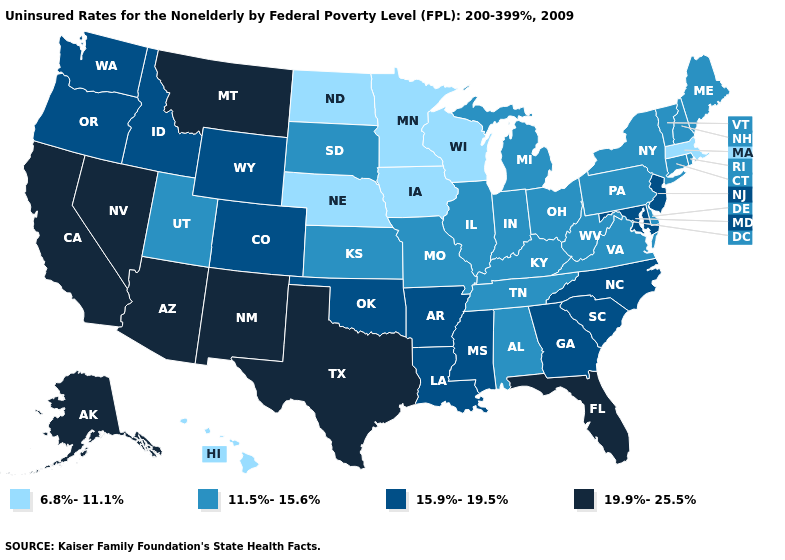What is the value of Maine?
Be succinct. 11.5%-15.6%. Name the states that have a value in the range 6.8%-11.1%?
Answer briefly. Hawaii, Iowa, Massachusetts, Minnesota, Nebraska, North Dakota, Wisconsin. Among the states that border Kansas , which have the lowest value?
Keep it brief. Nebraska. What is the value of Florida?
Keep it brief. 19.9%-25.5%. Among the states that border Indiana , which have the highest value?
Short answer required. Illinois, Kentucky, Michigan, Ohio. Name the states that have a value in the range 6.8%-11.1%?
Answer briefly. Hawaii, Iowa, Massachusetts, Minnesota, Nebraska, North Dakota, Wisconsin. Does Minnesota have a higher value than Maryland?
Keep it brief. No. Which states have the lowest value in the USA?
Answer briefly. Hawaii, Iowa, Massachusetts, Minnesota, Nebraska, North Dakota, Wisconsin. Name the states that have a value in the range 11.5%-15.6%?
Quick response, please. Alabama, Connecticut, Delaware, Illinois, Indiana, Kansas, Kentucky, Maine, Michigan, Missouri, New Hampshire, New York, Ohio, Pennsylvania, Rhode Island, South Dakota, Tennessee, Utah, Vermont, Virginia, West Virginia. What is the value of Wisconsin?
Concise answer only. 6.8%-11.1%. What is the highest value in the USA?
Keep it brief. 19.9%-25.5%. How many symbols are there in the legend?
Quick response, please. 4. Name the states that have a value in the range 6.8%-11.1%?
Give a very brief answer. Hawaii, Iowa, Massachusetts, Minnesota, Nebraska, North Dakota, Wisconsin. Name the states that have a value in the range 6.8%-11.1%?
Quick response, please. Hawaii, Iowa, Massachusetts, Minnesota, Nebraska, North Dakota, Wisconsin. Does Alabama have the highest value in the USA?
Quick response, please. No. 